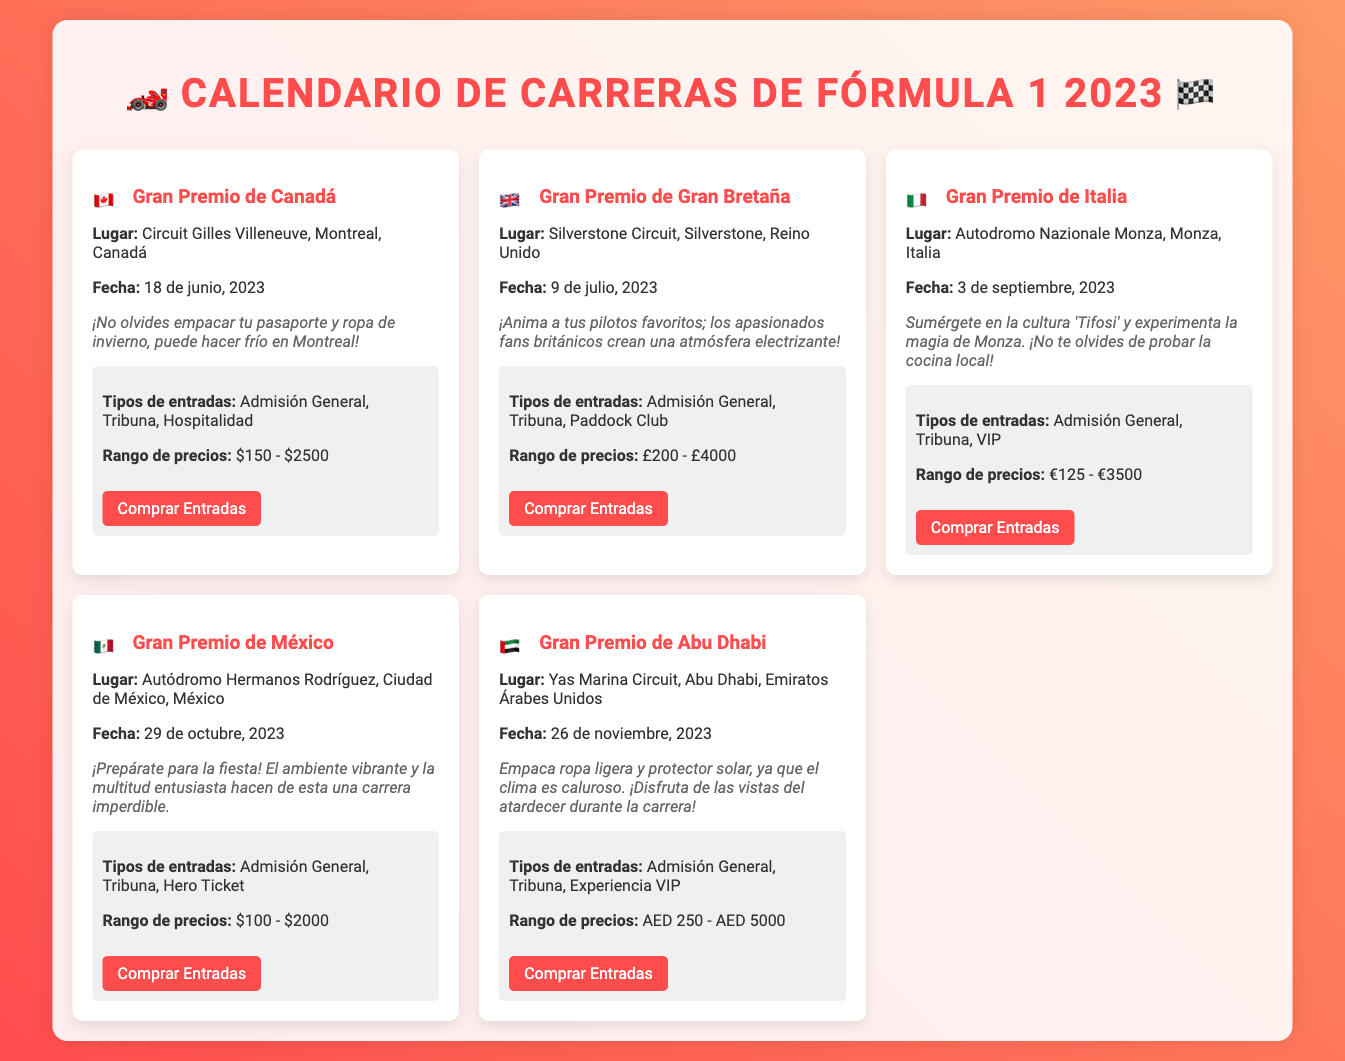¿Cuál es la fecha del Gran Premio de Canadá? La fecha del Gran Premio de Canadá es el 18 de junio, 2023.
Answer: 18 de junio, 2023 ¿Qué tipo de entradas están disponibles para el Gran Premio de México? Para el Gran Premio de México, los tipos de entradas son Admisión General, Tribuna, y Hero Ticket.
Answer: Admisión General, Tribuna, Hero Ticket ¿Cuánto cuestan las entradas para el Gran Premio de Italia? El rango de precios de las entradas para el Gran Premio de Italia es de 125 a 3500 euros.
Answer: €125 - €3500 ¿Cuál es el lugar del Gran Premio de Gran Bretaña? El lugar del Gran Premio de Gran Bretaña es Silverstone Circuit, Silverstone, Reino Unido.
Answer: Silverstone Circuit, Silverstone, Reino Unido ¿Qué consejo se da para el Gran Premio de Abu Dhabi? Se aconseja empacar ropa ligera y protector solar debido al clima caluroso.
Answer: Ropa ligera y protector solar 